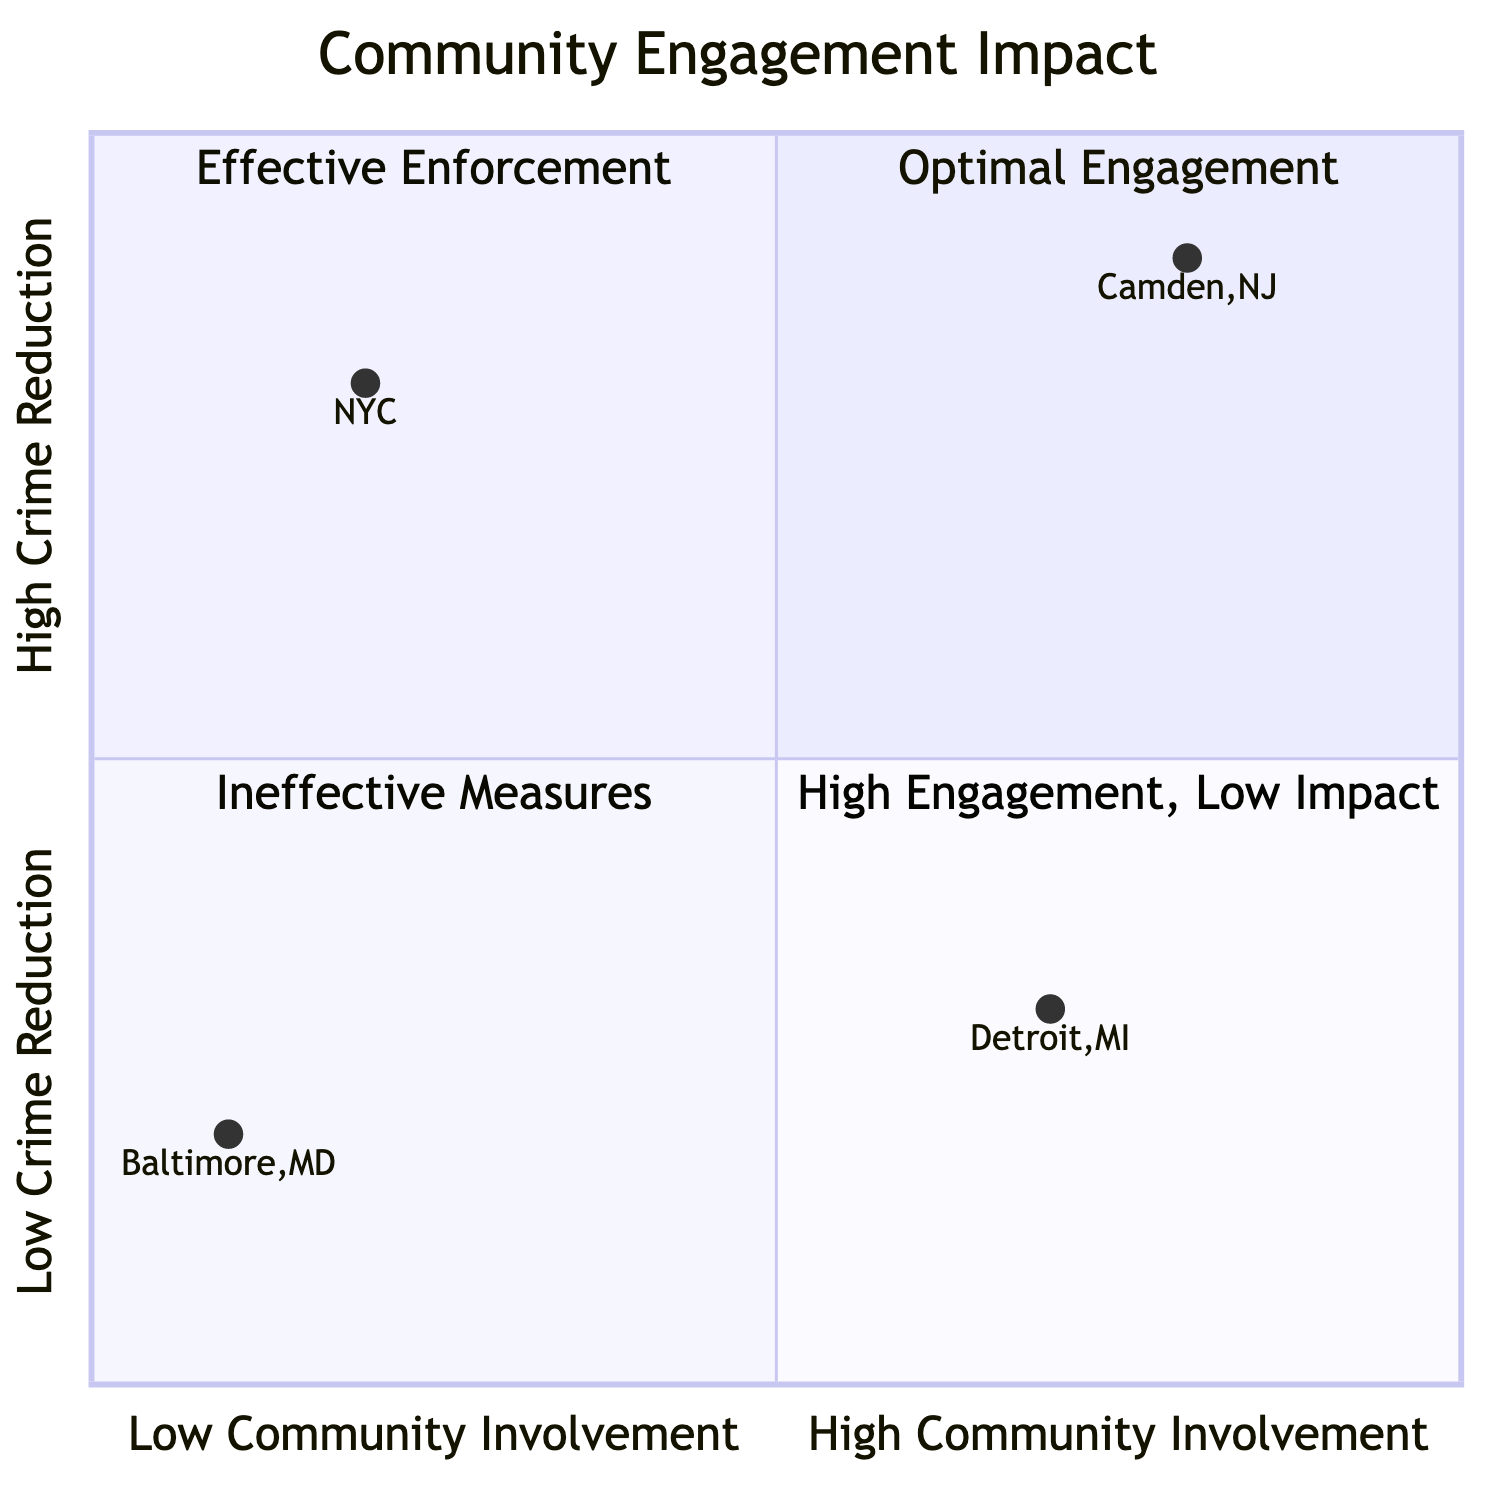What is the title of the quadrant where Camden, NJ is located? Camden, NJ coordinates are [0.8, 0.9], which places it in the first quadrant. The title for this quadrant is "Optimal Engagement."
Answer: Optimal Engagement Which quadrant has the least community involvement and the lowest crime reduction? Baltimore, MD is located at [0.1, 0.2], which is in the fourth quadrant labeled "Ineffective Measures." This quadrant represents minimal community involvement and low crime reduction.
Answer: Ineffective Measures How many quadrants are present in the diagram? There are four distinct quadrants displayed in the diagram: Optimal Engagement, Effective Enforcement, High Engagement, Low Impact, and Ineffective Measures.
Answer: Four What is the description of the "Effective Enforcement" quadrant? This quadrant focuses on the police's authoritative methods with little community interaction, aimed at stringent law enforcement practices, exemplified by New York City's CompStat.
Answer: "Efforts where the police force remains primarily authoritative with minimal community interaction, focusing on stringent law enforcement." Which location has the highest community involvement? Based on the coordinates, Camden, NJ at [0.8, 0.9] shows the highest level of community involvement of all locations plotted on the chart.
Answer: Camden, NJ What can be inferred about community involvement in Detroit, MI compared to NYC? Detroit, MI ([0.7, 0.3]) has higher community involvement than NYC ([0.2, 0.8]), despite both showing suboptimal crime reduction results.
Answer: Higher community involvement In which quadrant is Detroit, MI located? Detroit, MI has coordinates of [0.7, 0.3], placing it in the fourth quadrant labeled "High Engagement, Low Impact."
Answer: High Engagement, Low Impact What does the y-coordinate for NYC represent? The y-coordinate of NYC is 0.8, indicating a high crime reduction as represented in the chart’s context of crime reduction on the vertical axis.
Answer: 0.8 Which quadrant represents programs with extensive community participation but high crime rates? The description of the second quadrant includes initiatives like those of Detroit, MI, showing extensive community participation with stubbornly high crime rates.
Answer: High Engagement, Low Impact 